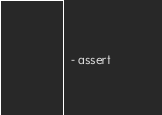Convert code to text. <code><loc_0><loc_0><loc_500><loc_500><_YAML_>  - assert
</code> 